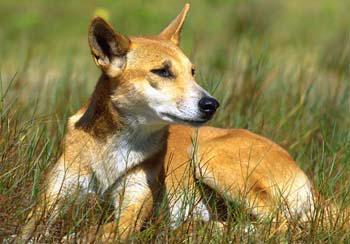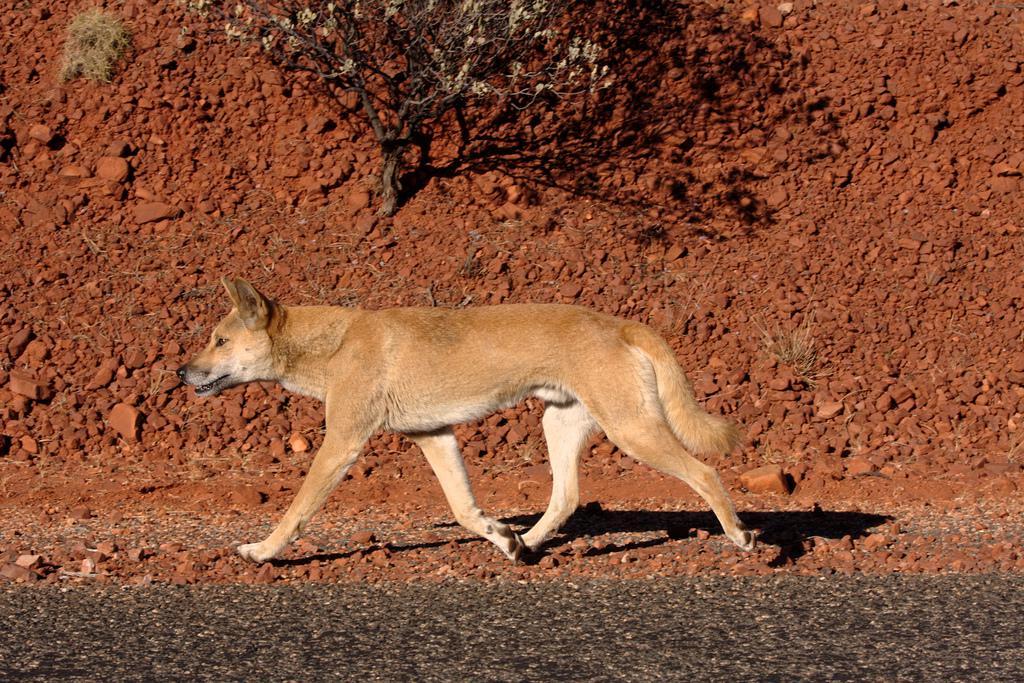The first image is the image on the left, the second image is the image on the right. Analyze the images presented: Is the assertion "The canine on the left is laying down, the canine on the right is standing up." valid? Answer yes or no. Yes. The first image is the image on the left, the second image is the image on the right. For the images shown, is this caption "One of the images shows exactly one animal in the grass alone." true? Answer yes or no. Yes. The first image is the image on the left, the second image is the image on the right. Analyze the images presented: Is the assertion "there are two animals" valid? Answer yes or no. Yes. 